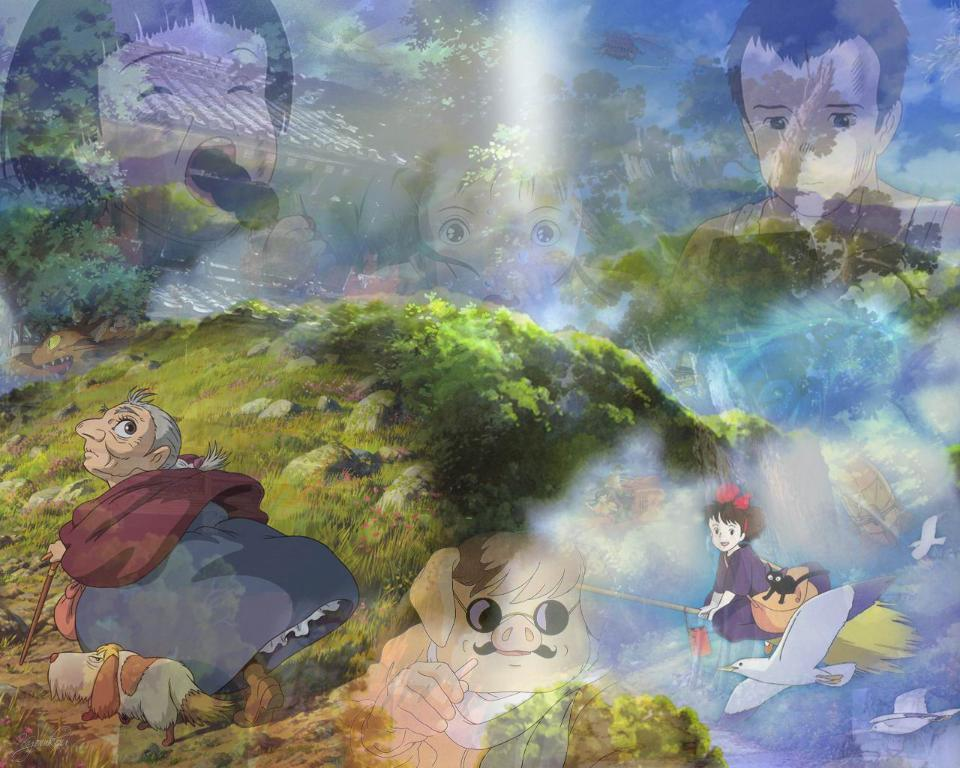What types of living beings are present in the image? There are people, animals, and birds in the image. What is the natural environment like in the image? The natural environment includes grass, trees, and the sky. What type of structures can be seen in the image? There are houses in the image. What color is the ink used by the birds in the image? There is no ink present in the image, as birds do not use ink. 